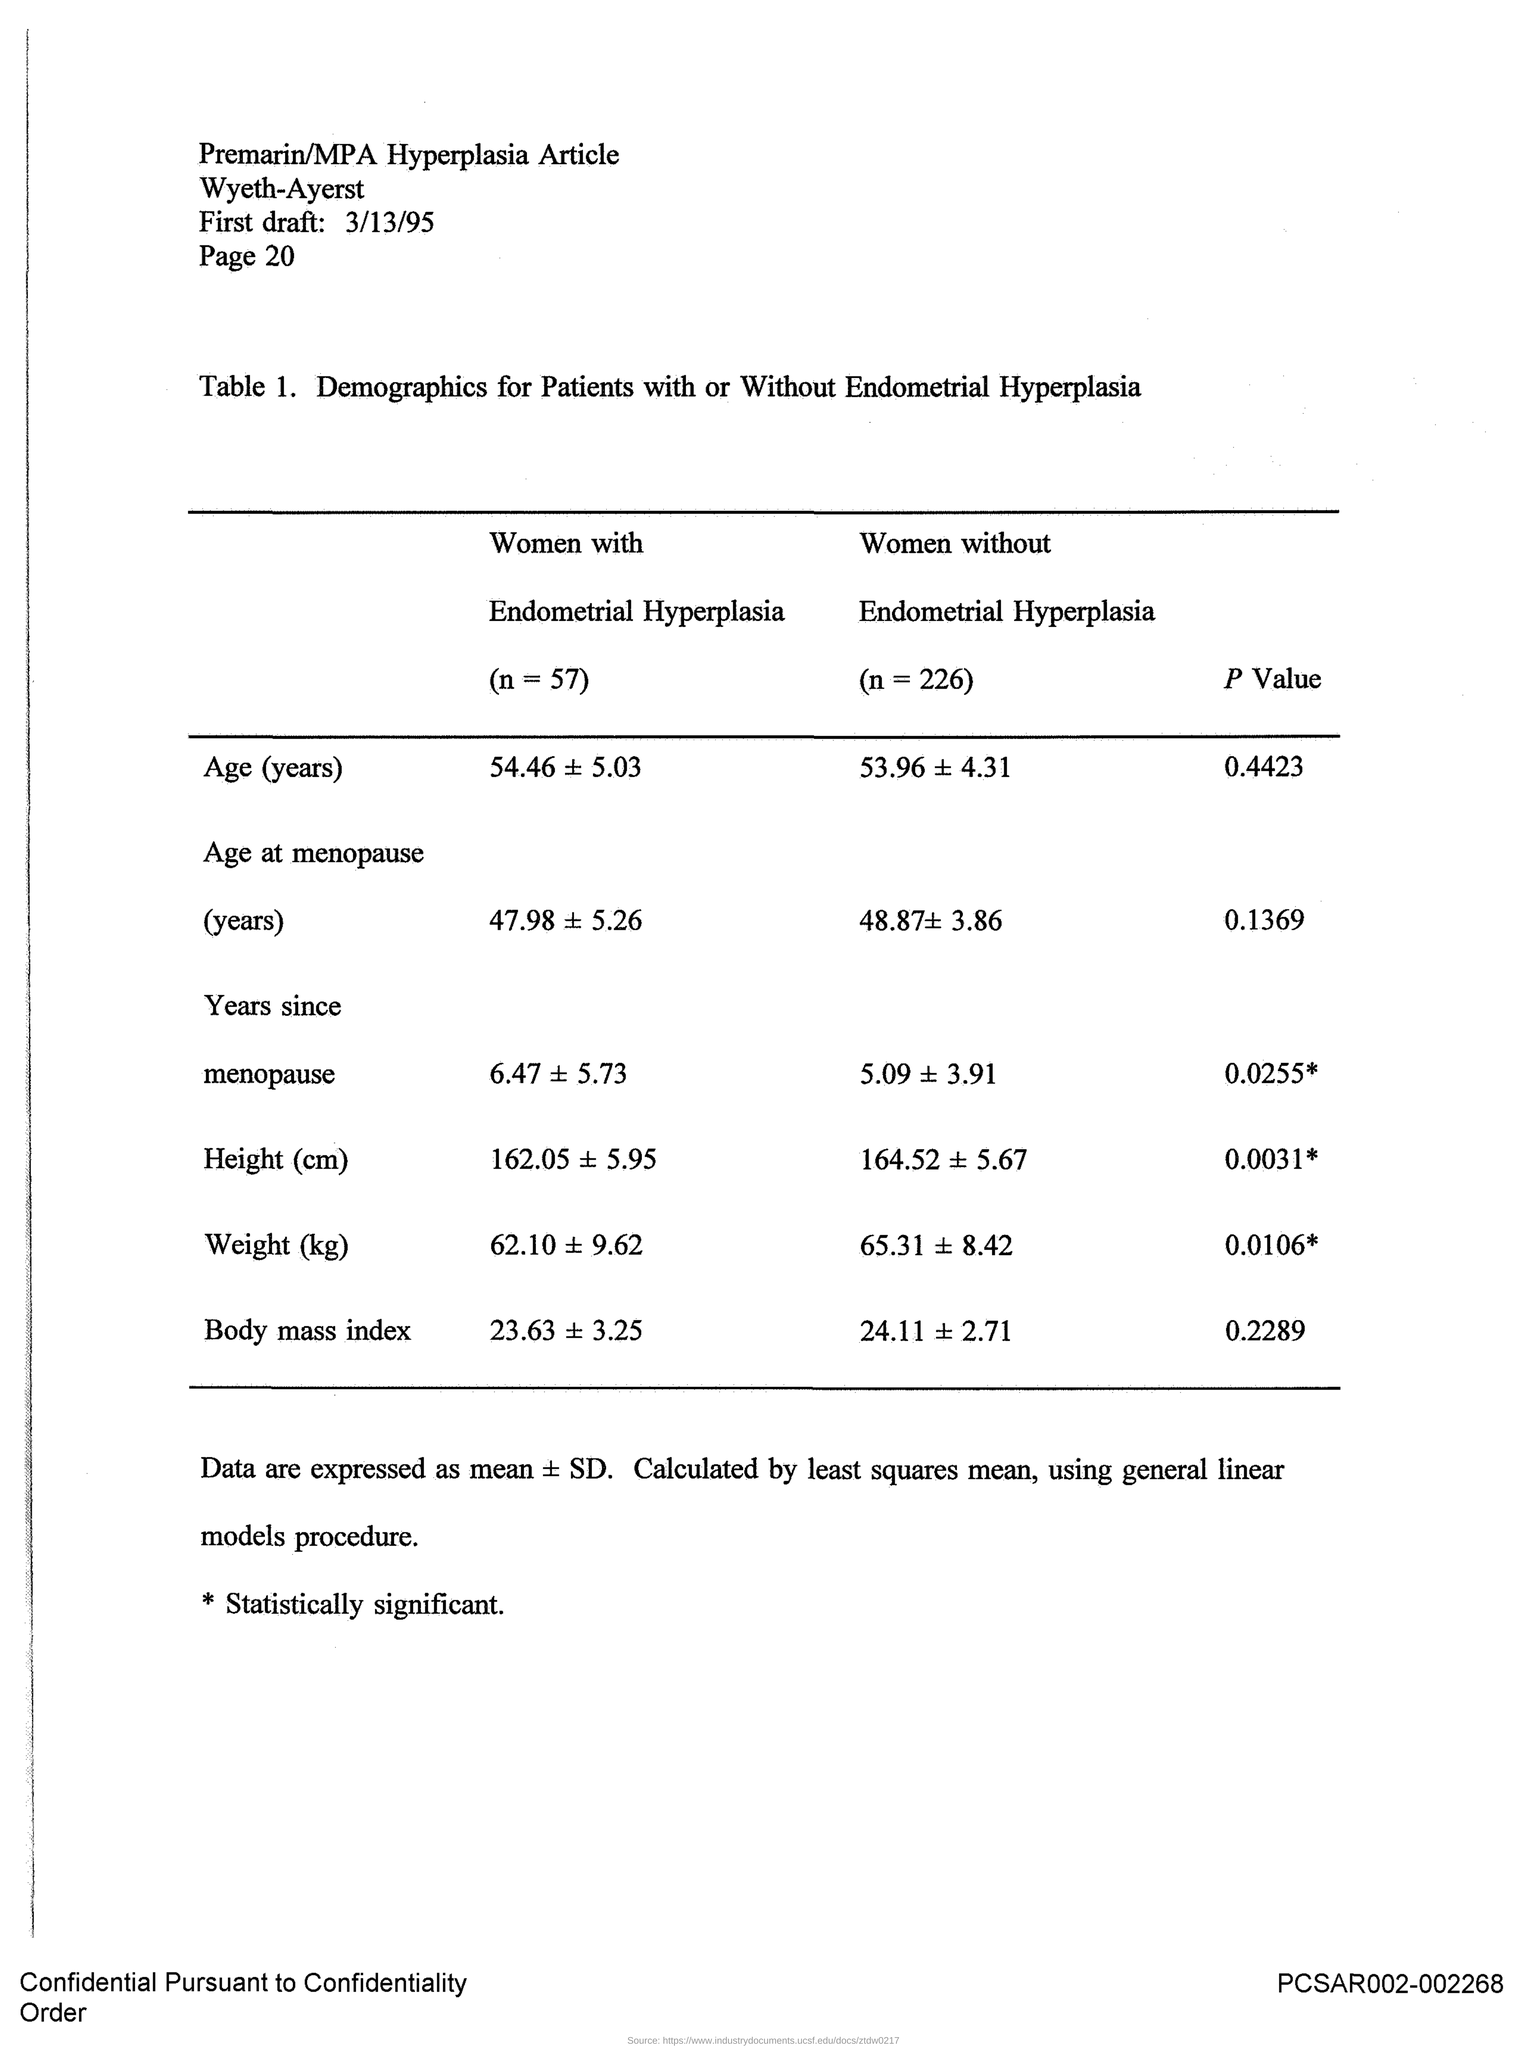Mention a couple of crucial points in this snapshot. The P value of body mass index is 0.2289. There are 226 women without Endometrial Hyperplasia. The P value of Age is 0.4423, which indicates that there is weak evidence against the null hypothesis that the mean age is equal to 0. There are 57 women with Endometrial Hyperplasia. 